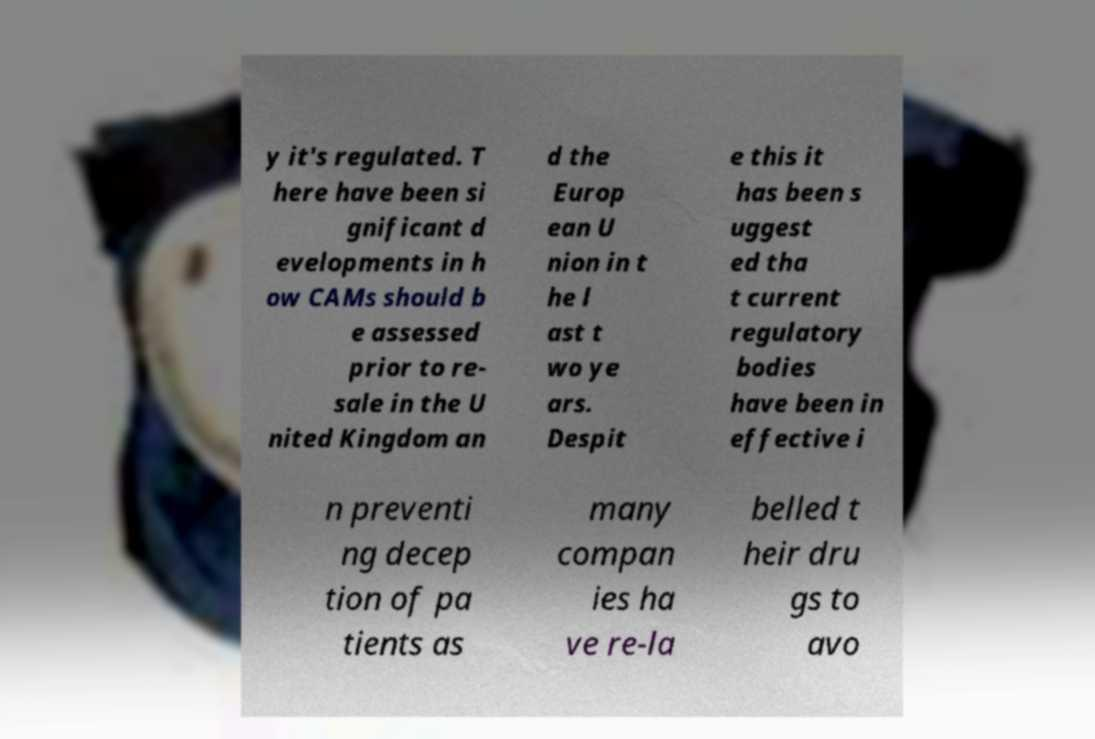Can you read and provide the text displayed in the image?This photo seems to have some interesting text. Can you extract and type it out for me? y it's regulated. T here have been si gnificant d evelopments in h ow CAMs should b e assessed prior to re- sale in the U nited Kingdom an d the Europ ean U nion in t he l ast t wo ye ars. Despit e this it has been s uggest ed tha t current regulatory bodies have been in effective i n preventi ng decep tion of pa tients as many compan ies ha ve re-la belled t heir dru gs to avo 